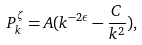Convert formula to latex. <formula><loc_0><loc_0><loc_500><loc_500>P _ { k } ^ { \zeta } = A ( k ^ { - 2 \epsilon } - \frac { C } { k ^ { 2 } } ) ,</formula> 